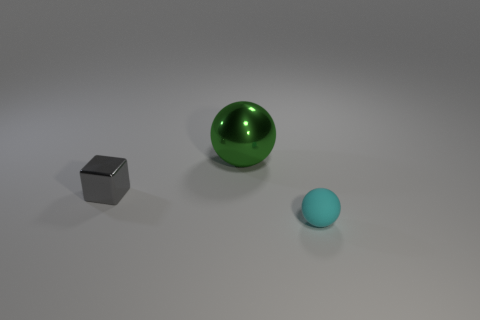Add 2 cyan things. How many objects exist? 5 Subtract all cubes. How many objects are left? 2 Add 3 matte balls. How many matte balls exist? 4 Subtract 0 gray spheres. How many objects are left? 3 Subtract all cubes. Subtract all large metallic things. How many objects are left? 1 Add 2 small cyan matte objects. How many small cyan matte objects are left? 3 